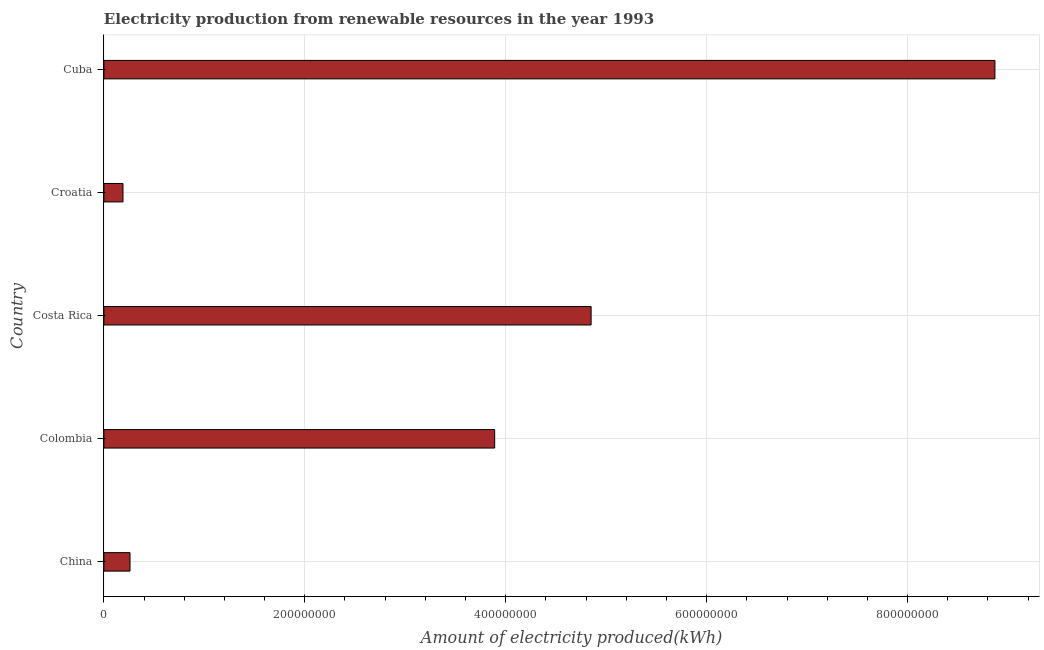What is the title of the graph?
Your answer should be very brief. Electricity production from renewable resources in the year 1993. What is the label or title of the X-axis?
Give a very brief answer. Amount of electricity produced(kWh). What is the amount of electricity produced in China?
Provide a short and direct response. 2.60e+07. Across all countries, what is the maximum amount of electricity produced?
Keep it short and to the point. 8.87e+08. Across all countries, what is the minimum amount of electricity produced?
Offer a very short reply. 1.90e+07. In which country was the amount of electricity produced maximum?
Keep it short and to the point. Cuba. In which country was the amount of electricity produced minimum?
Your answer should be compact. Croatia. What is the sum of the amount of electricity produced?
Your answer should be very brief. 1.81e+09. What is the difference between the amount of electricity produced in China and Colombia?
Keep it short and to the point. -3.63e+08. What is the average amount of electricity produced per country?
Provide a short and direct response. 3.61e+08. What is the median amount of electricity produced?
Make the answer very short. 3.89e+08. What is the ratio of the amount of electricity produced in Costa Rica to that in Cuba?
Provide a succinct answer. 0.55. Is the difference between the amount of electricity produced in China and Costa Rica greater than the difference between any two countries?
Your response must be concise. No. What is the difference between the highest and the second highest amount of electricity produced?
Your answer should be very brief. 4.02e+08. Is the sum of the amount of electricity produced in China and Cuba greater than the maximum amount of electricity produced across all countries?
Give a very brief answer. Yes. What is the difference between the highest and the lowest amount of electricity produced?
Give a very brief answer. 8.68e+08. In how many countries, is the amount of electricity produced greater than the average amount of electricity produced taken over all countries?
Your answer should be very brief. 3. Are all the bars in the graph horizontal?
Provide a short and direct response. Yes. What is the difference between two consecutive major ticks on the X-axis?
Your response must be concise. 2.00e+08. Are the values on the major ticks of X-axis written in scientific E-notation?
Make the answer very short. No. What is the Amount of electricity produced(kWh) in China?
Your response must be concise. 2.60e+07. What is the Amount of electricity produced(kWh) in Colombia?
Your answer should be very brief. 3.89e+08. What is the Amount of electricity produced(kWh) in Costa Rica?
Ensure brevity in your answer.  4.85e+08. What is the Amount of electricity produced(kWh) in Croatia?
Keep it short and to the point. 1.90e+07. What is the Amount of electricity produced(kWh) in Cuba?
Keep it short and to the point. 8.87e+08. What is the difference between the Amount of electricity produced(kWh) in China and Colombia?
Ensure brevity in your answer.  -3.63e+08. What is the difference between the Amount of electricity produced(kWh) in China and Costa Rica?
Keep it short and to the point. -4.59e+08. What is the difference between the Amount of electricity produced(kWh) in China and Cuba?
Offer a terse response. -8.61e+08. What is the difference between the Amount of electricity produced(kWh) in Colombia and Costa Rica?
Offer a terse response. -9.60e+07. What is the difference between the Amount of electricity produced(kWh) in Colombia and Croatia?
Your answer should be very brief. 3.70e+08. What is the difference between the Amount of electricity produced(kWh) in Colombia and Cuba?
Your response must be concise. -4.98e+08. What is the difference between the Amount of electricity produced(kWh) in Costa Rica and Croatia?
Offer a terse response. 4.66e+08. What is the difference between the Amount of electricity produced(kWh) in Costa Rica and Cuba?
Offer a terse response. -4.02e+08. What is the difference between the Amount of electricity produced(kWh) in Croatia and Cuba?
Keep it short and to the point. -8.68e+08. What is the ratio of the Amount of electricity produced(kWh) in China to that in Colombia?
Your answer should be very brief. 0.07. What is the ratio of the Amount of electricity produced(kWh) in China to that in Costa Rica?
Offer a very short reply. 0.05. What is the ratio of the Amount of electricity produced(kWh) in China to that in Croatia?
Provide a succinct answer. 1.37. What is the ratio of the Amount of electricity produced(kWh) in China to that in Cuba?
Your answer should be very brief. 0.03. What is the ratio of the Amount of electricity produced(kWh) in Colombia to that in Costa Rica?
Keep it short and to the point. 0.8. What is the ratio of the Amount of electricity produced(kWh) in Colombia to that in Croatia?
Make the answer very short. 20.47. What is the ratio of the Amount of electricity produced(kWh) in Colombia to that in Cuba?
Provide a short and direct response. 0.44. What is the ratio of the Amount of electricity produced(kWh) in Costa Rica to that in Croatia?
Ensure brevity in your answer.  25.53. What is the ratio of the Amount of electricity produced(kWh) in Costa Rica to that in Cuba?
Provide a short and direct response. 0.55. What is the ratio of the Amount of electricity produced(kWh) in Croatia to that in Cuba?
Give a very brief answer. 0.02. 